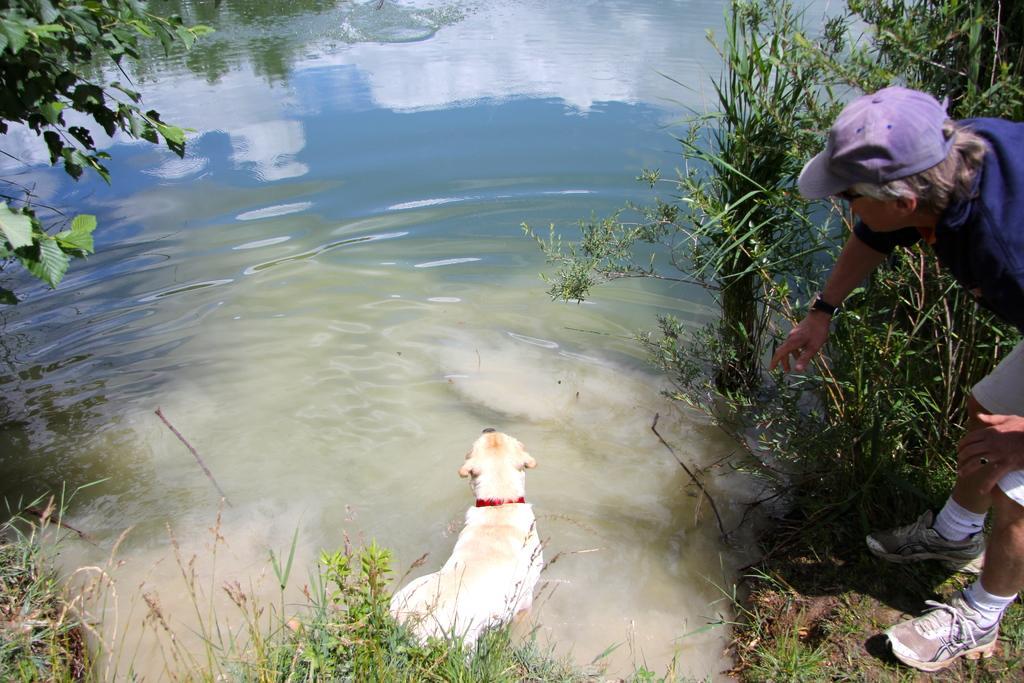How would you summarize this image in a sentence or two? This image consists of water. At the bottom, we can see a dog and green grass. On the left and right, there are plants. On the right, we can see a person wearing a blue cap. 